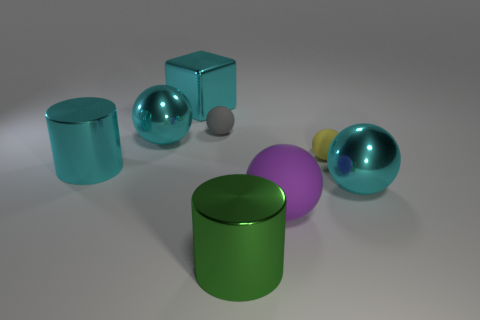Subtract 2 balls. How many balls are left? 3 Subtract all yellow spheres. How many spheres are left? 4 Subtract all purple spheres. How many spheres are left? 4 Subtract all blue spheres. Subtract all red blocks. How many spheres are left? 5 Add 1 large green cylinders. How many objects exist? 9 Subtract all cubes. How many objects are left? 7 Add 5 cyan shiny cylinders. How many cyan shiny cylinders are left? 6 Add 6 large yellow metal objects. How many large yellow metal objects exist? 6 Subtract 1 cyan cubes. How many objects are left? 7 Subtract all big green shiny cylinders. Subtract all large gray matte cylinders. How many objects are left? 7 